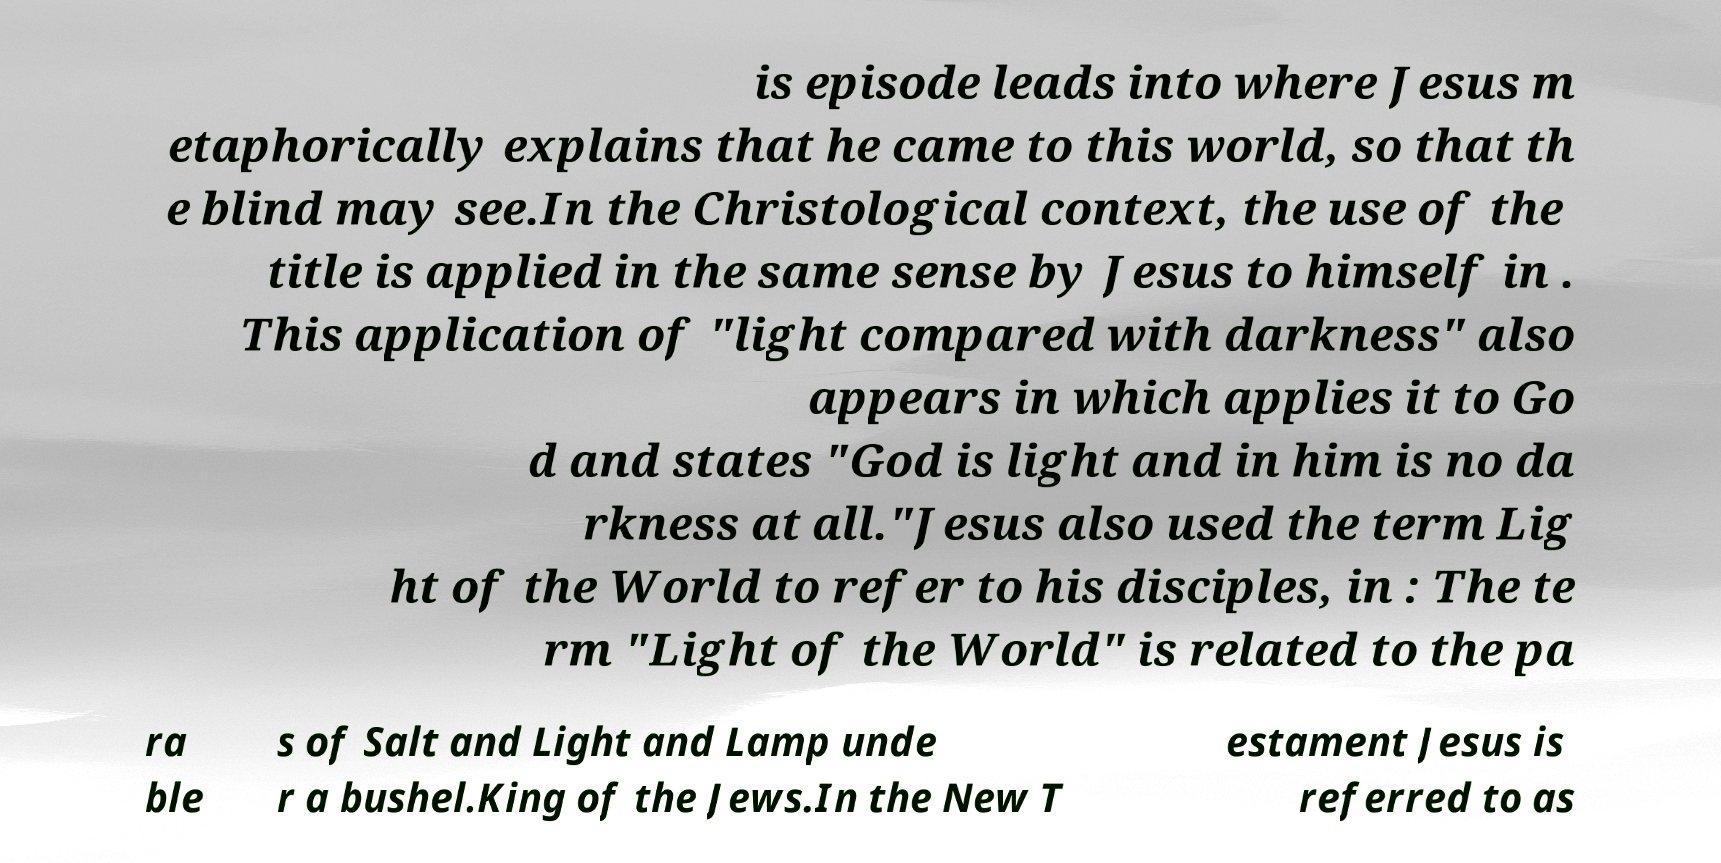Can you read and provide the text displayed in the image?This photo seems to have some interesting text. Can you extract and type it out for me? is episode leads into where Jesus m etaphorically explains that he came to this world, so that th e blind may see.In the Christological context, the use of the title is applied in the same sense by Jesus to himself in . This application of "light compared with darkness" also appears in which applies it to Go d and states "God is light and in him is no da rkness at all."Jesus also used the term Lig ht of the World to refer to his disciples, in : The te rm "Light of the World" is related to the pa ra ble s of Salt and Light and Lamp unde r a bushel.King of the Jews.In the New T estament Jesus is referred to as 